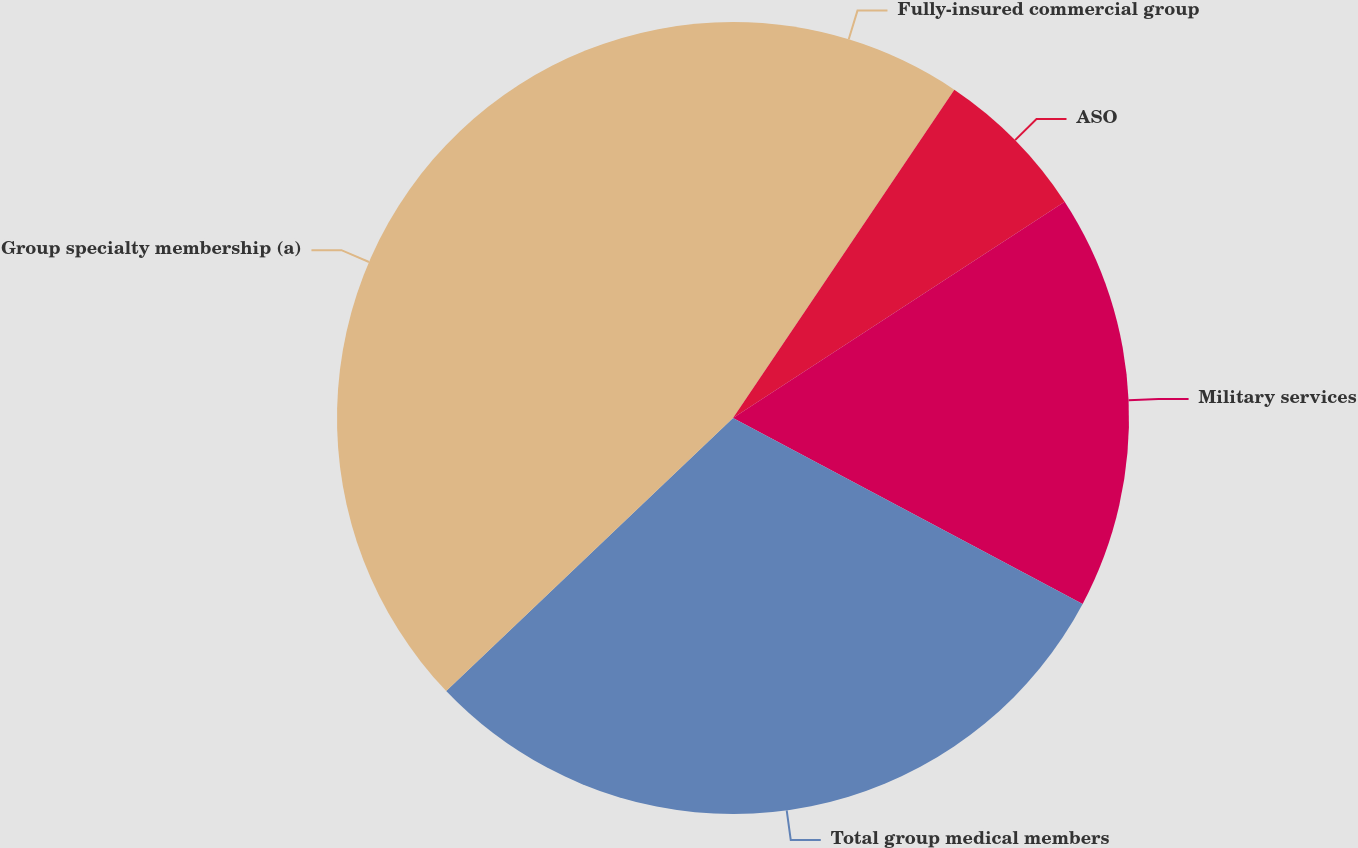<chart> <loc_0><loc_0><loc_500><loc_500><pie_chart><fcel>Fully-insured commercial group<fcel>ASO<fcel>Military services<fcel>Total group medical members<fcel>Group specialty membership (a)<nl><fcel>9.44%<fcel>6.36%<fcel>16.98%<fcel>30.11%<fcel>37.11%<nl></chart> 